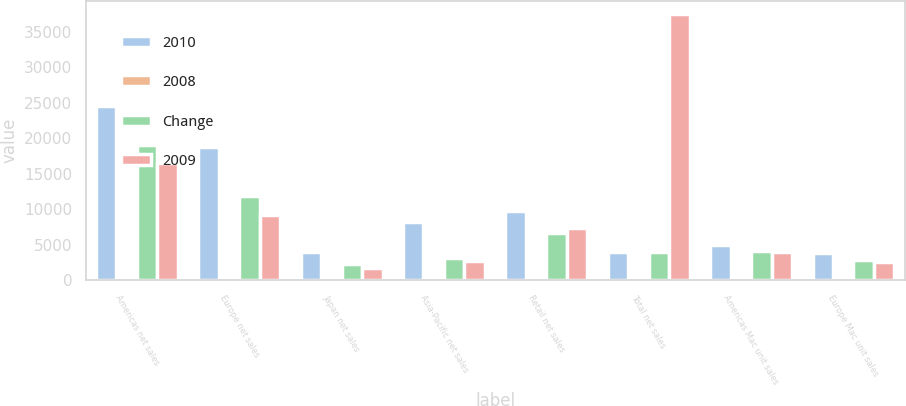Convert chart to OTSL. <chart><loc_0><loc_0><loc_500><loc_500><stacked_bar_chart><ecel><fcel>Americas net sales<fcel>Europe net sales<fcel>Japan net sales<fcel>Asia-Pacific net sales<fcel>Retail net sales<fcel>Total net sales<fcel>Americas Mac unit sales<fcel>Europe Mac unit sales<nl><fcel>2010<fcel>24498<fcel>18692<fcel>3981<fcel>8256<fcel>9798<fcel>3919.5<fcel>4976<fcel>3859<nl><fcel>2008<fcel>29<fcel>58<fcel>75<fcel>160<fcel>47<fcel>52<fcel>21<fcel>36<nl><fcel>Change<fcel>18981<fcel>11810<fcel>2279<fcel>3179<fcel>6656<fcel>3919.5<fcel>4120<fcel>2840<nl><fcel>2009<fcel>16552<fcel>9233<fcel>1728<fcel>2686<fcel>7292<fcel>37491<fcel>3980<fcel>2519<nl></chart> 